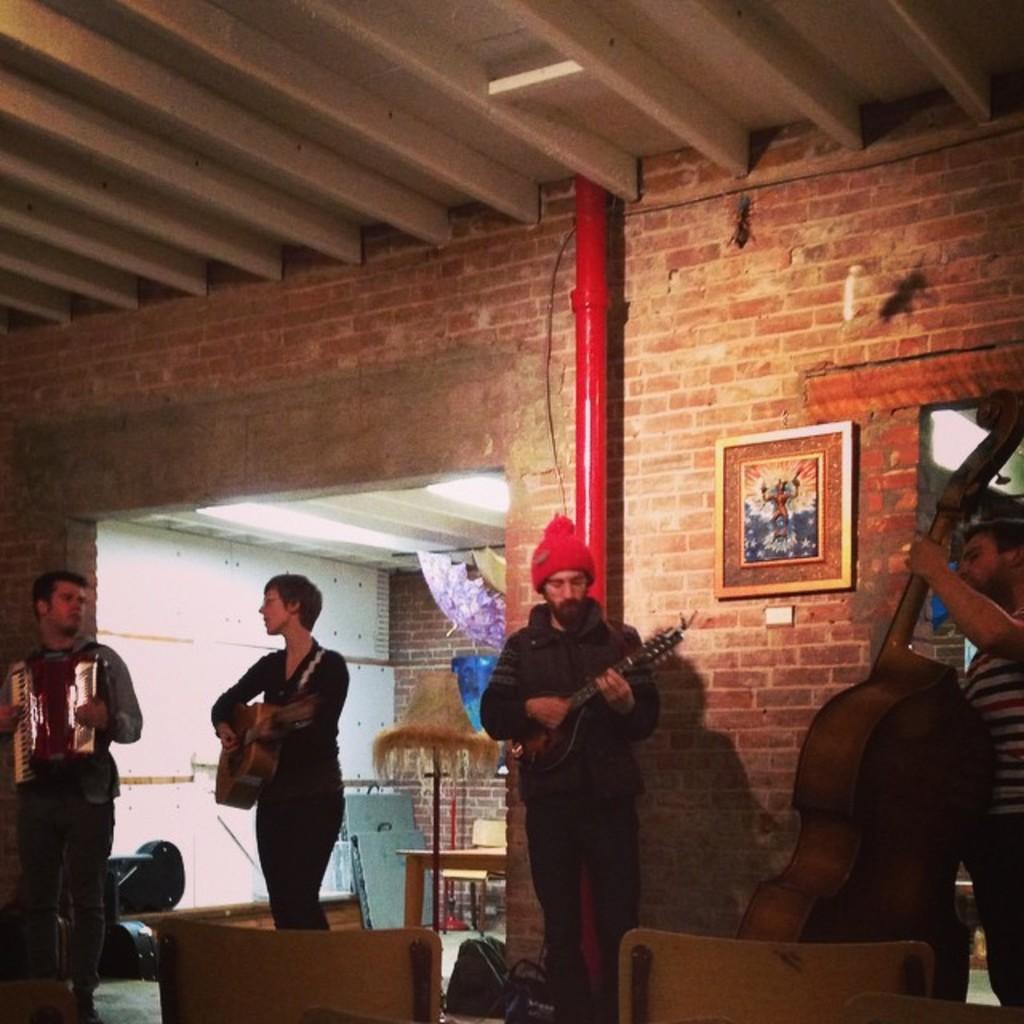Please provide a concise description of this image. This image is taken inside a room, there are four people in this room. At the background there is a wall and a pipe and a frame on it. At the top of the image there is a roof. In the left side of the image there is a man standing and playing a musical instrument. In the middle of the image a man is standing and holding a guitar in his hand. In the right side of the image there is a man standing and holding a guitar. 